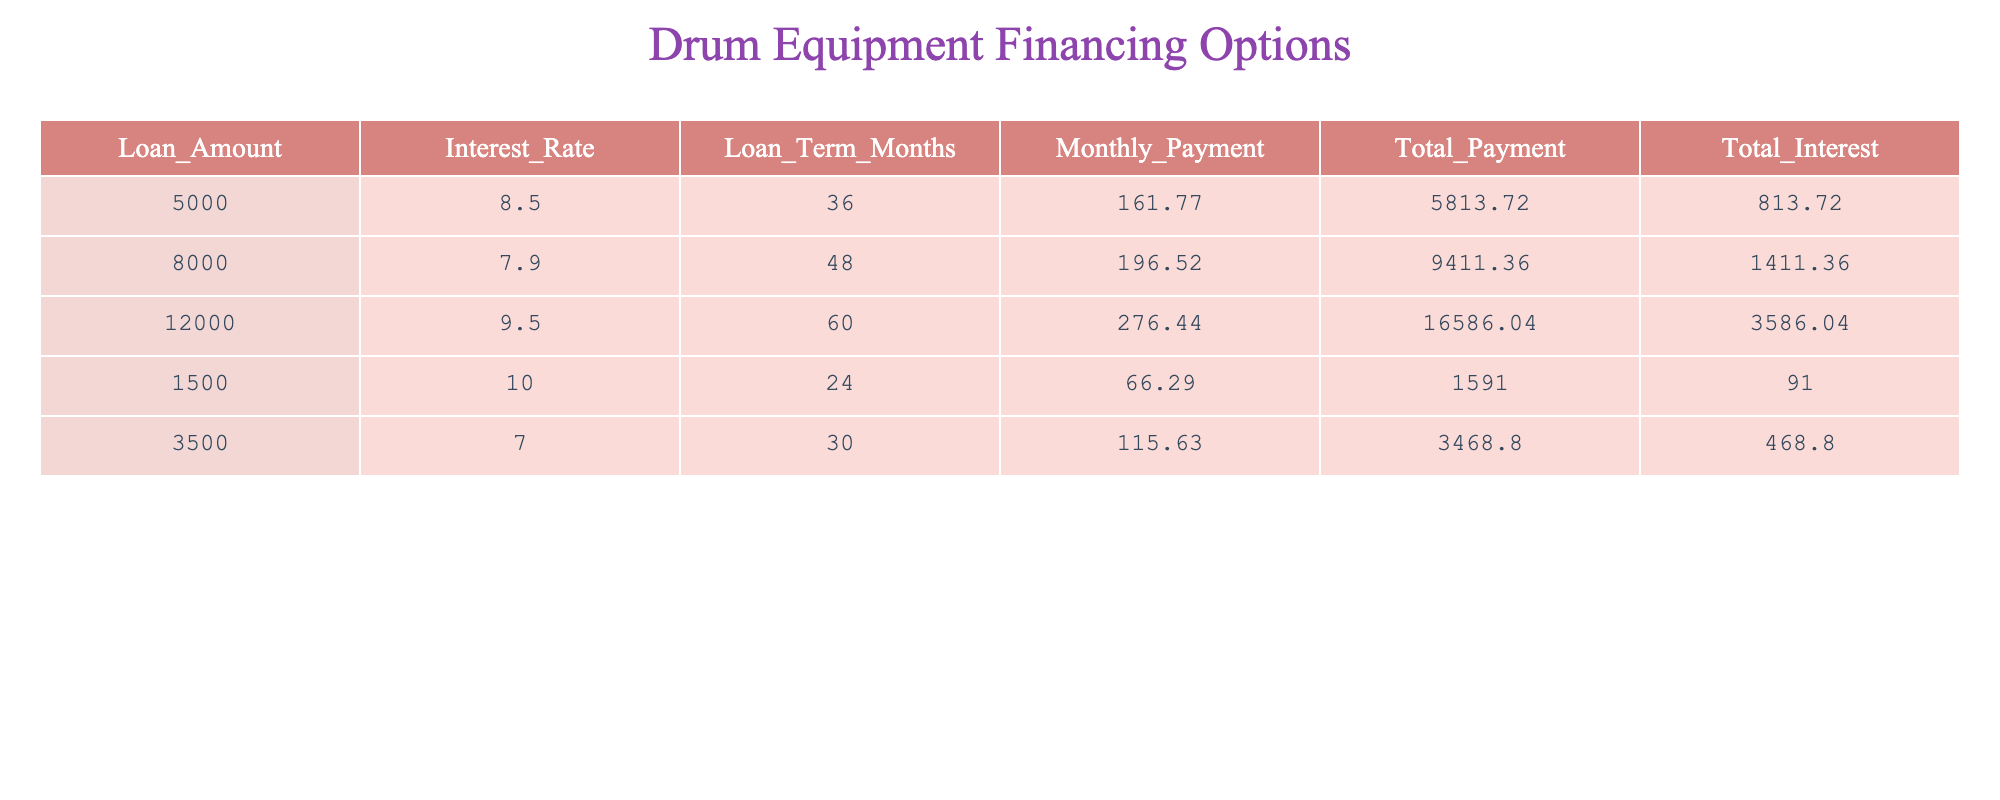What is the loan amount for the option with the highest interest rate? The table shows several loan options along with their interest rates. The highest interest rate is 10.0%, which corresponds to the loan amount of 1500.
Answer: 1500 What is the total interest paid for a loan of 8000? In the table, the total interest for the loan amount of 8000 is explicitly listed as 1411.36.
Answer: 1411.36 What is the difference in monthly payment between the loans of 5000 and 3500? For the loan of 5000, the monthly payment is 161.77, and for 3500, it is 115.63. The difference is 161.77 - 115.63 = 46.14.
Answer: 46.14 Is the total payment for the loan of 12000 greater than the sum of total payments for the loans of amounts 5000 and 3500? The total payment for 12000 is 16586.04. The sum of total payments for 5000 (5813.72) and 3500 (3468.80) is 5813.72 + 3468.80 = 9282.52. Since 16586.04 is greater than 9282.52, the answer is Yes.
Answer: Yes What is the average monthly payment of the loans listed? To find the average monthly payment, we first sum the monthly payments: 161.77 + 196.52 + 276.44 + 66.29 + 115.63 = 816.65. There are 5 loans, thus the average monthly payment is 816.65 / 5 = 163.33.
Answer: 163.33 What loan amount has the lowest total payment? The loan amount of 1500 has the lowest total payment of 1591.00 according to the table.
Answer: 1500 Is the interest rate for the loan amount of 3500 lower than the rate for the loan of 8000? The interest rate for the loan of 3500 is 7.0%, while for the loan of 8000, it is 7.9%. Since 7.0% is less than 7.9%, the answer is Yes.
Answer: Yes What is the total interest paid across all loans? The total interest for all loans can be calculated by summing the individual total interest amounts: 813.72 + 1411.36 + 3586.04 + 91.00 + 468.80 = 6290.92.
Answer: 6290.92 